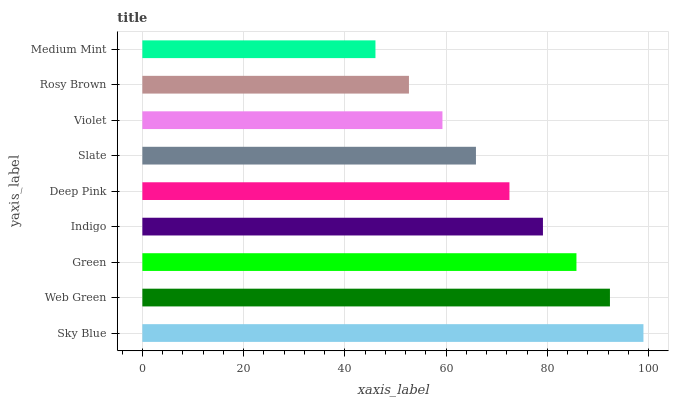Is Medium Mint the minimum?
Answer yes or no. Yes. Is Sky Blue the maximum?
Answer yes or no. Yes. Is Web Green the minimum?
Answer yes or no. No. Is Web Green the maximum?
Answer yes or no. No. Is Sky Blue greater than Web Green?
Answer yes or no. Yes. Is Web Green less than Sky Blue?
Answer yes or no. Yes. Is Web Green greater than Sky Blue?
Answer yes or no. No. Is Sky Blue less than Web Green?
Answer yes or no. No. Is Deep Pink the high median?
Answer yes or no. Yes. Is Deep Pink the low median?
Answer yes or no. Yes. Is Sky Blue the high median?
Answer yes or no. No. Is Slate the low median?
Answer yes or no. No. 